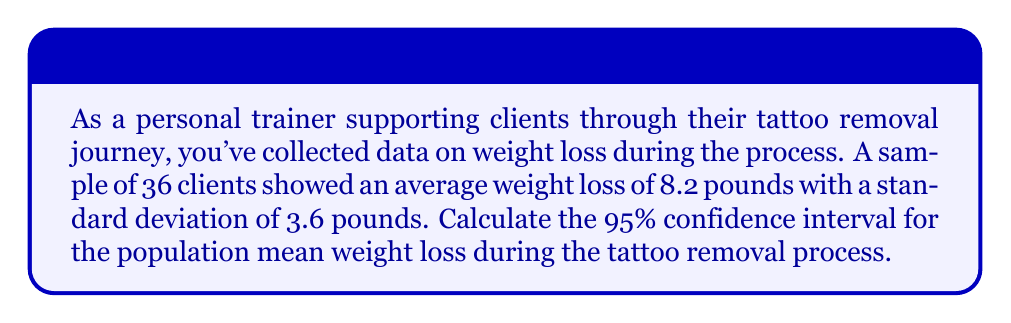Can you answer this question? To calculate the confidence interval, we'll follow these steps:

1) The formula for the confidence interval is:

   $$\bar{x} \pm t_{\alpha/2} \cdot \frac{s}{\sqrt{n}}$$

   Where:
   $\bar{x}$ is the sample mean
   $t_{\alpha/2}$ is the t-value for the desired confidence level
   $s$ is the sample standard deviation
   $n$ is the sample size

2) We know:
   $\bar{x} = 8.2$ pounds
   $s = 3.6$ pounds
   $n = 36$
   Confidence level = 95%, so $\alpha = 0.05$

3) For a 95% confidence interval with 35 degrees of freedom (n-1), the t-value is approximately 2.030 (from t-distribution table).

4) Plugging into the formula:

   $$8.2 \pm 2.030 \cdot \frac{3.6}{\sqrt{36}}$$

5) Simplify:
   $$8.2 \pm 2.030 \cdot \frac{3.6}{6}$$
   $$8.2 \pm 2.030 \cdot 0.6$$
   $$8.2 \pm 1.218$$

6) Calculate the interval:
   Lower bound: $8.2 - 1.218 = 6.982$
   Upper bound: $8.2 + 1.218 = 9.418$

Therefore, we are 95% confident that the population mean weight loss during the tattoo removal process is between 6.982 and 9.418 pounds.
Answer: (6.982, 9.418) pounds 